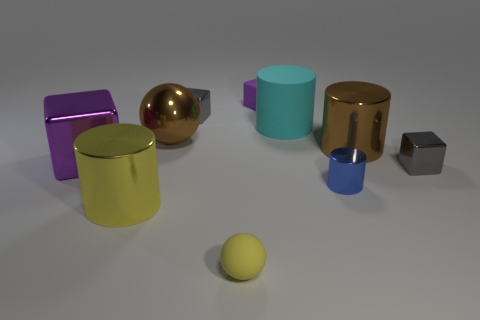The purple matte cube has what size?
Ensure brevity in your answer.  Small. How many cylinders are either large red rubber objects or big metallic objects?
Provide a short and direct response. 2. The brown sphere that is made of the same material as the blue object is what size?
Keep it short and to the point. Large. What number of matte objects are the same color as the big metallic cube?
Your response must be concise. 1. There is a purple metallic cube; are there any small metallic objects in front of it?
Provide a succinct answer. Yes. Do the large purple metallic thing and the yellow rubber thing in front of the yellow metal thing have the same shape?
Your answer should be very brief. No. What number of objects are large shiny objects on the right side of the yellow metallic cylinder or small spheres?
Keep it short and to the point. 3. What number of cylinders are both in front of the big metal block and to the right of the matte cylinder?
Give a very brief answer. 1. How many objects are either matte objects behind the big yellow cylinder or things that are behind the big purple metallic block?
Your answer should be compact. 5. How many other objects are there of the same shape as the large yellow object?
Your answer should be very brief. 3. 